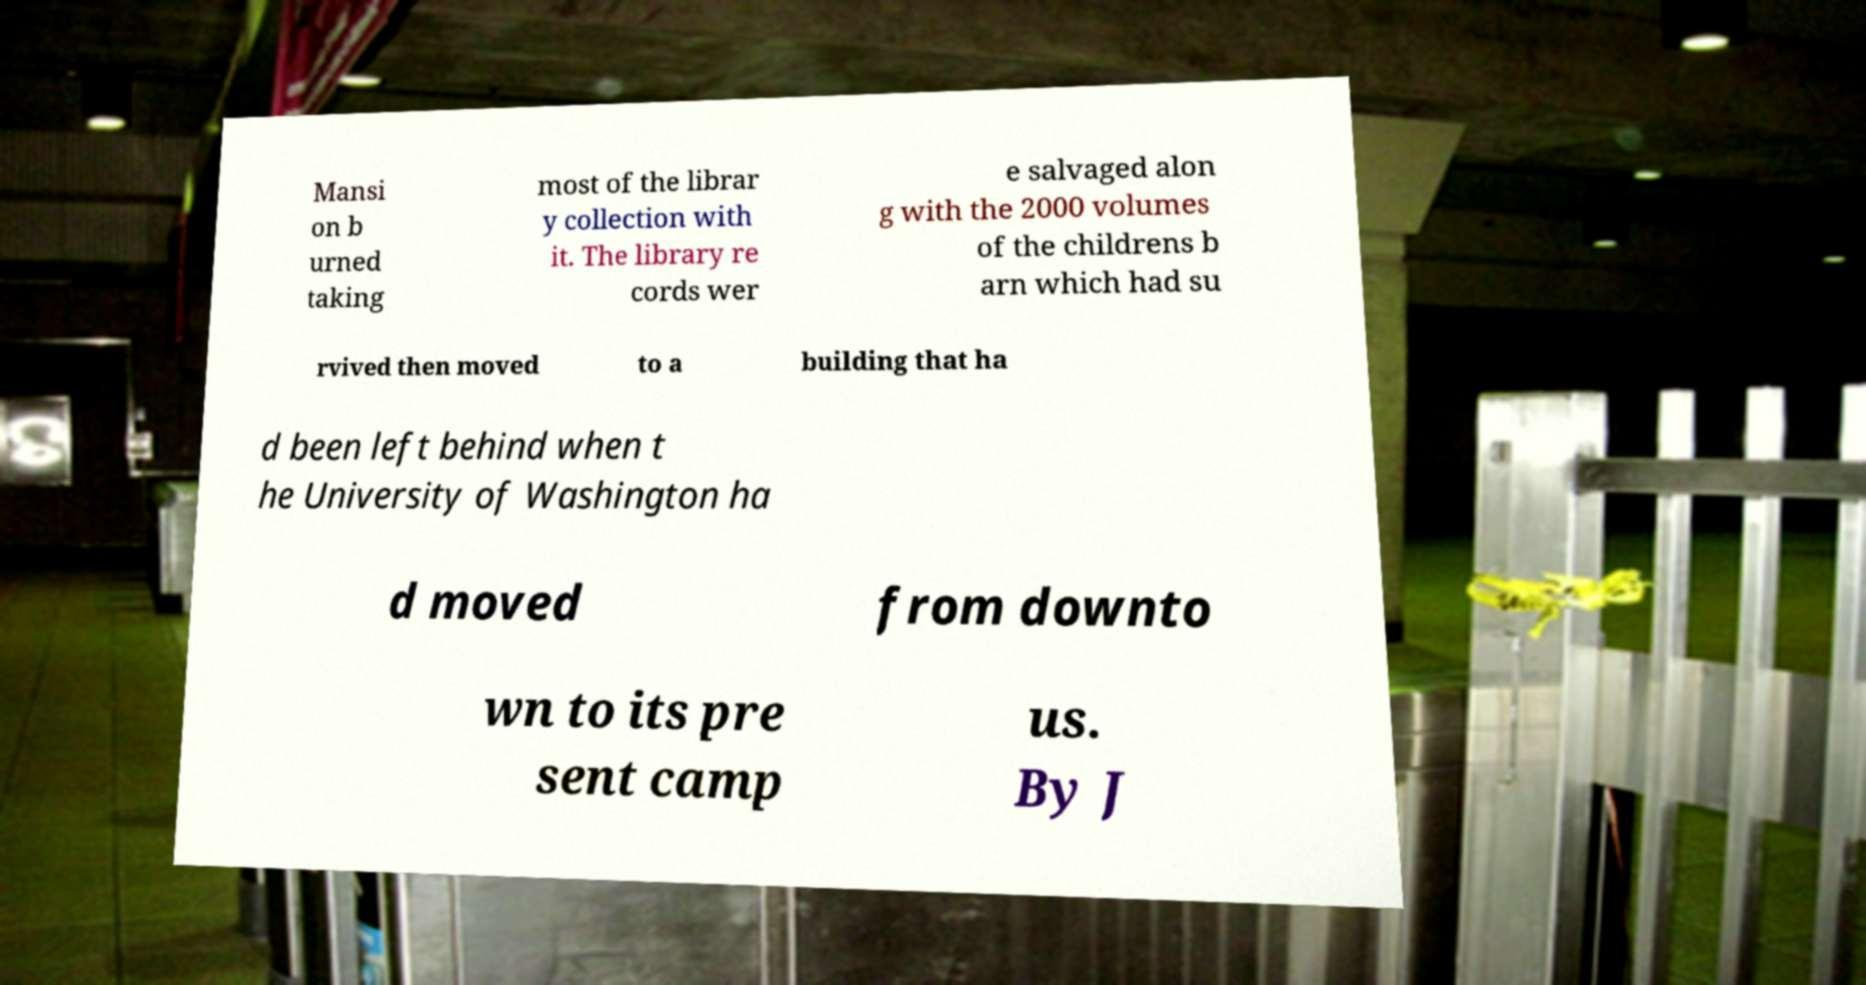Can you accurately transcribe the text from the provided image for me? Mansi on b urned taking most of the librar y collection with it. The library re cords wer e salvaged alon g with the 2000 volumes of the childrens b arn which had su rvived then moved to a building that ha d been left behind when t he University of Washington ha d moved from downto wn to its pre sent camp us. By J 